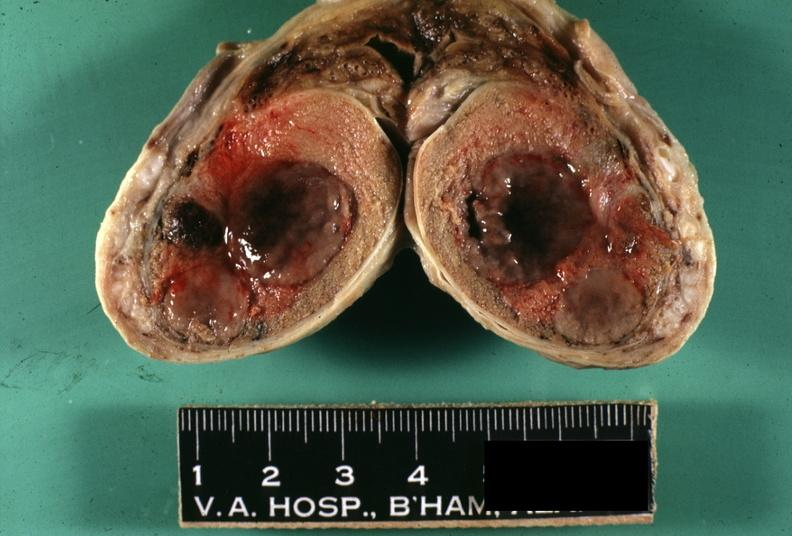does this image show fixed tissue tumor masses with necrosis easily seen?
Answer the question using a single word or phrase. Yes 